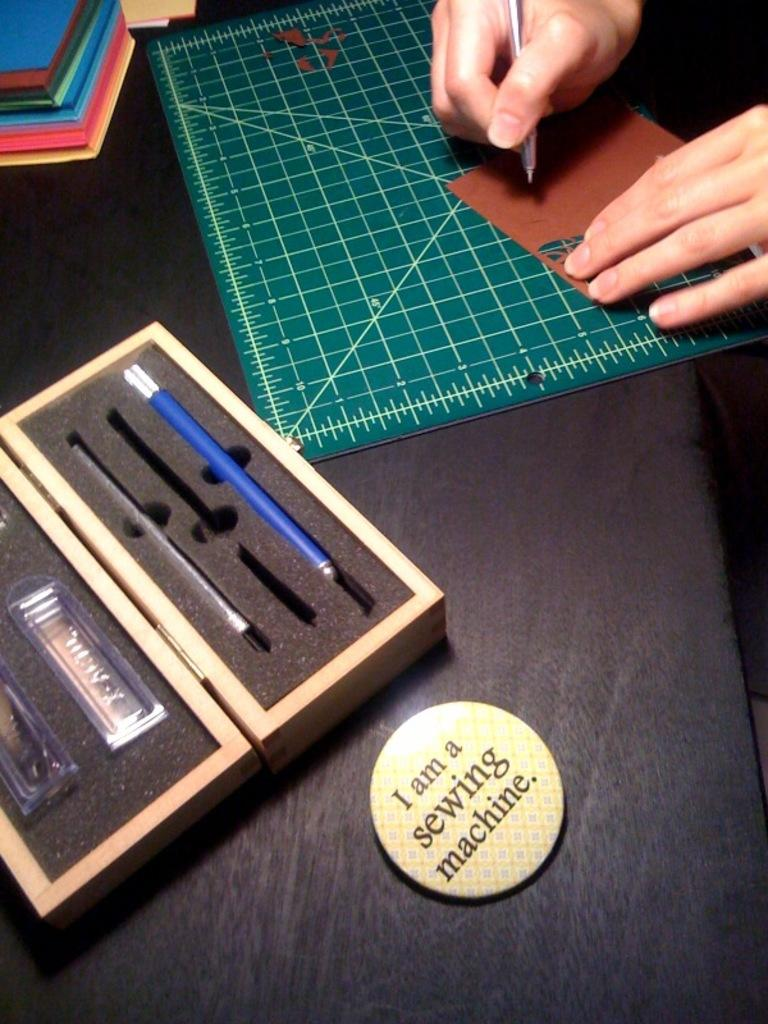Provide a one-sentence caption for the provided image. A button sitting on a drafting table claims itself to be a sewing machine. 